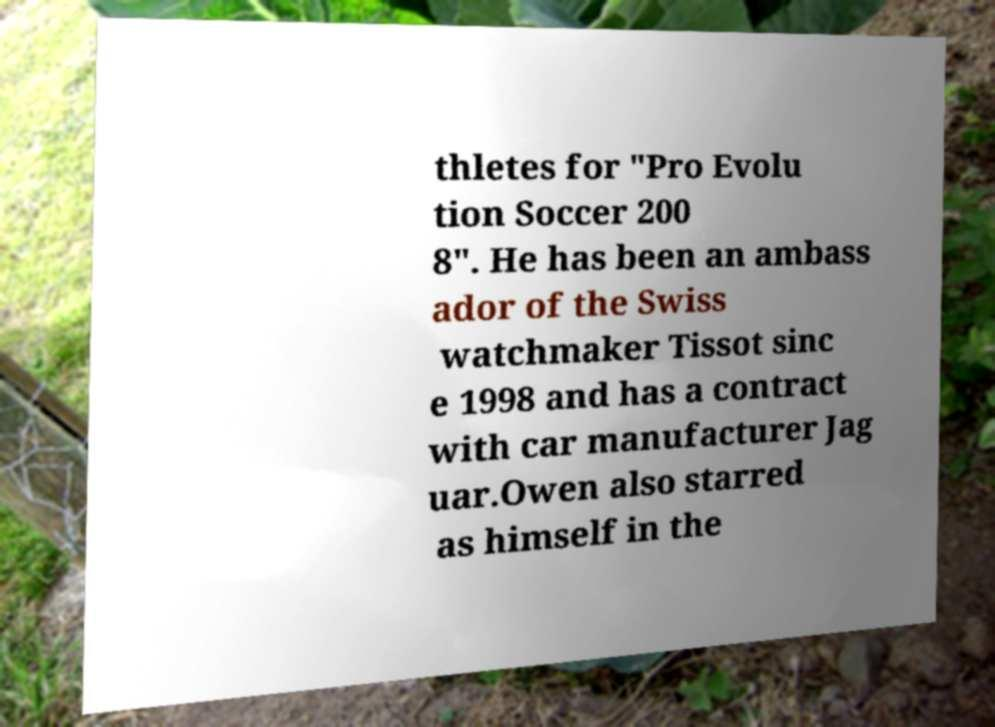There's text embedded in this image that I need extracted. Can you transcribe it verbatim? thletes for "Pro Evolu tion Soccer 200 8". He has been an ambass ador of the Swiss watchmaker Tissot sinc e 1998 and has a contract with car manufacturer Jag uar.Owen also starred as himself in the 